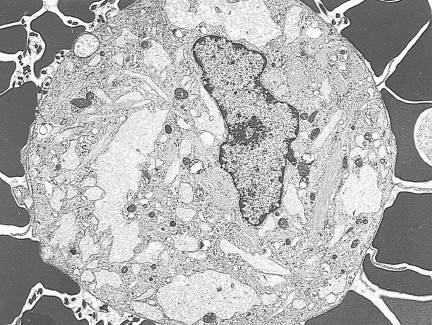what are electron micrograph of gaucher cells with?
Answer the question using a single word or phrase. Elongated distended lysosomes 